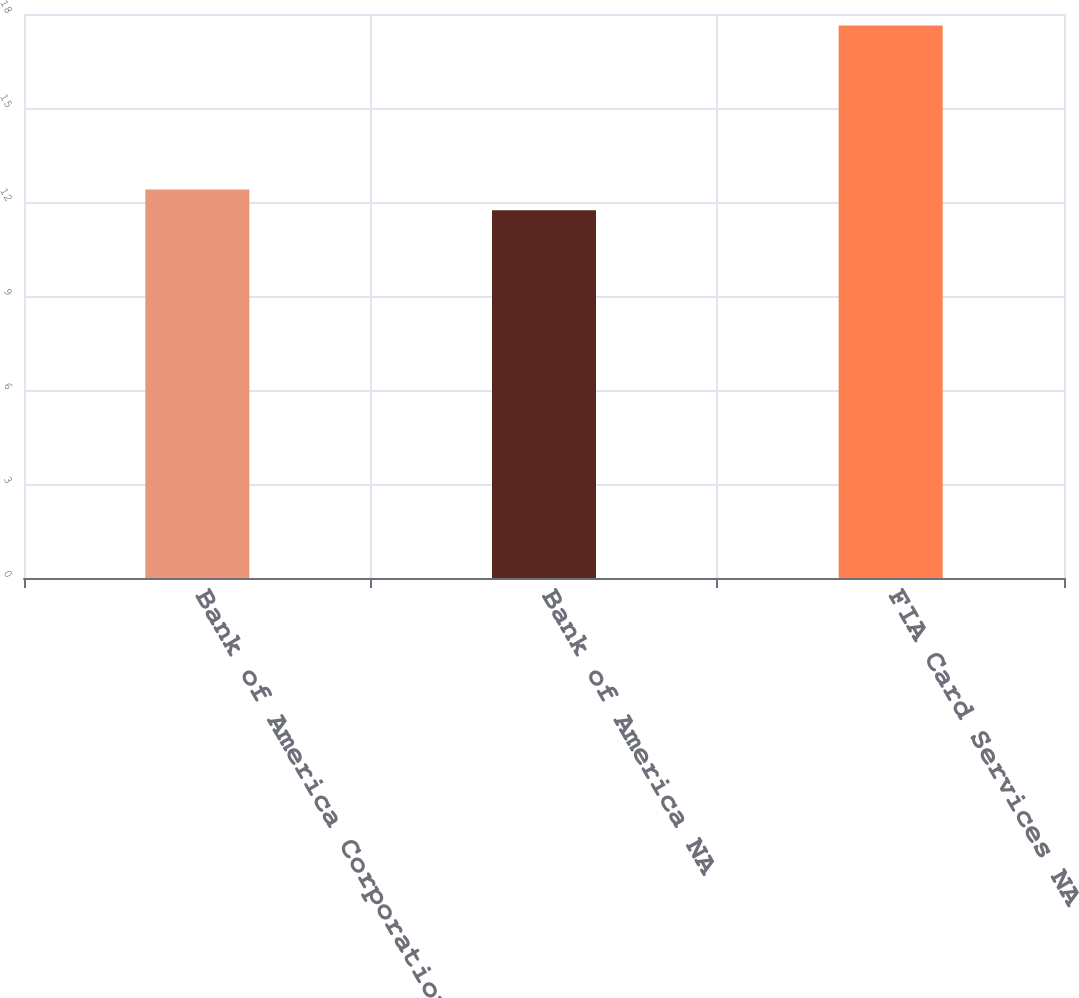Convert chart to OTSL. <chart><loc_0><loc_0><loc_500><loc_500><bar_chart><fcel>Bank of America Corporation<fcel>Bank of America NA<fcel>FIA Card Services NA<nl><fcel>12.4<fcel>11.74<fcel>17.63<nl></chart> 